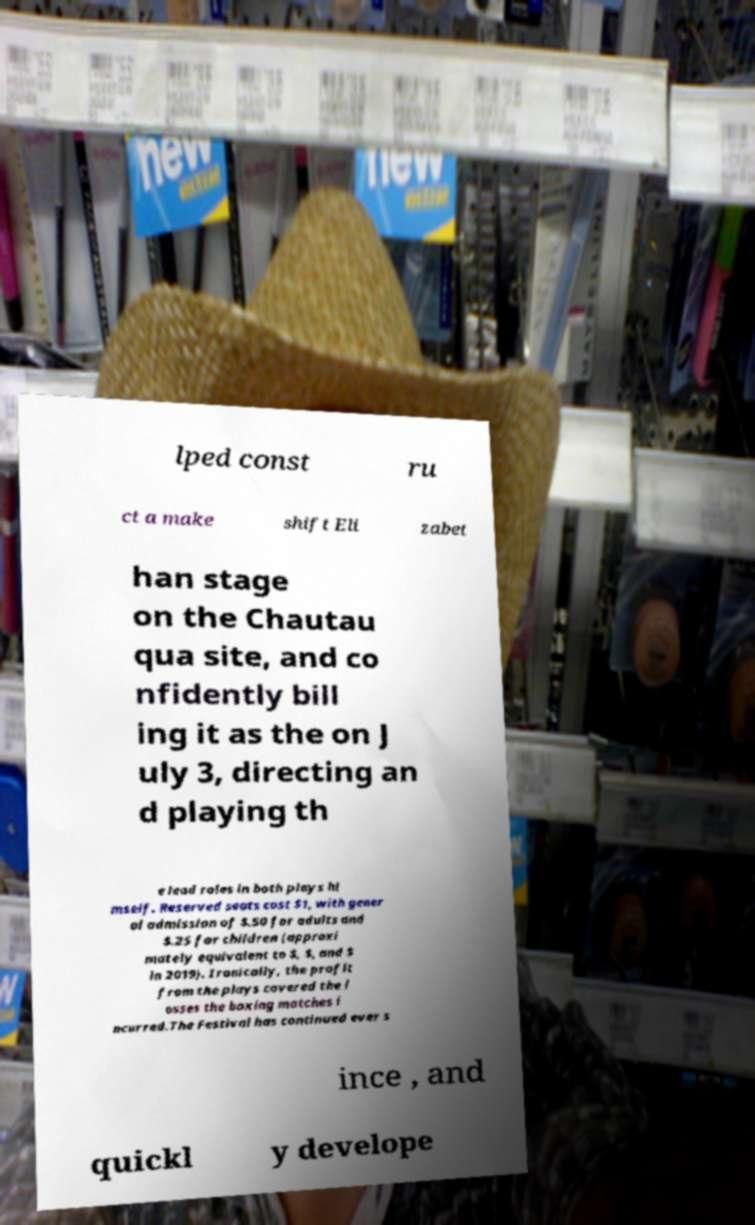There's text embedded in this image that I need extracted. Can you transcribe it verbatim? lped const ru ct a make shift Eli zabet han stage on the Chautau qua site, and co nfidently bill ing it as the on J uly 3, directing an d playing th e lead roles in both plays hi mself. Reserved seats cost $1, with gener al admission of $.50 for adults and $.25 for children (approxi mately equivalent to $, $, and $ in 2019). Ironically, the profit from the plays covered the l osses the boxing matches i ncurred.The Festival has continued ever s ince , and quickl y develope 